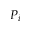Convert formula to latex. <formula><loc_0><loc_0><loc_500><loc_500>P _ { i }</formula> 